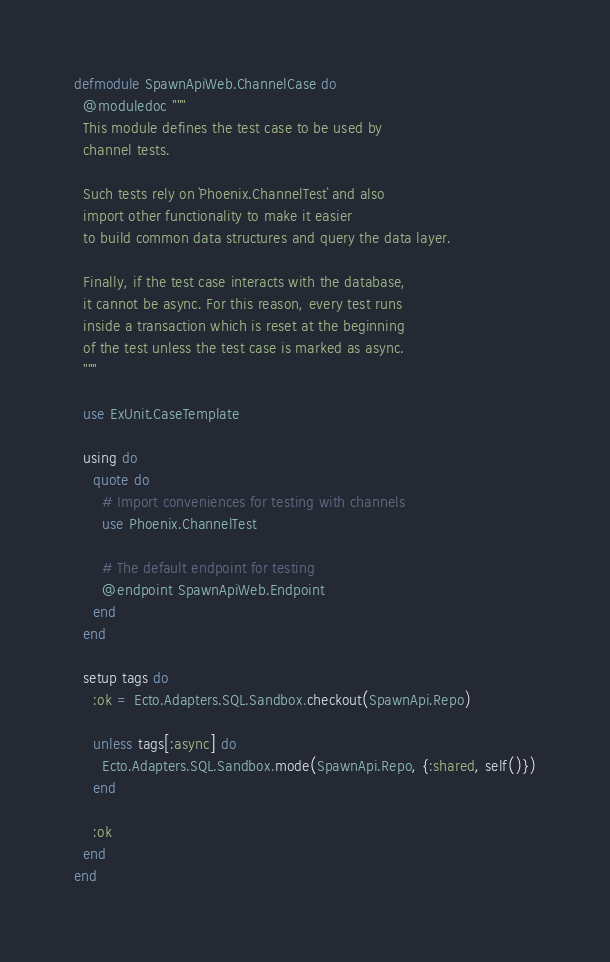<code> <loc_0><loc_0><loc_500><loc_500><_Elixir_>defmodule SpawnApiWeb.ChannelCase do
  @moduledoc """
  This module defines the test case to be used by
  channel tests.

  Such tests rely on `Phoenix.ChannelTest` and also
  import other functionality to make it easier
  to build common data structures and query the data layer.

  Finally, if the test case interacts with the database,
  it cannot be async. For this reason, every test runs
  inside a transaction which is reset at the beginning
  of the test unless the test case is marked as async.
  """

  use ExUnit.CaseTemplate

  using do
    quote do
      # Import conveniences for testing with channels
      use Phoenix.ChannelTest

      # The default endpoint for testing
      @endpoint SpawnApiWeb.Endpoint
    end
  end

  setup tags do
    :ok = Ecto.Adapters.SQL.Sandbox.checkout(SpawnApi.Repo)

    unless tags[:async] do
      Ecto.Adapters.SQL.Sandbox.mode(SpawnApi.Repo, {:shared, self()})
    end

    :ok
  end
end
</code> 